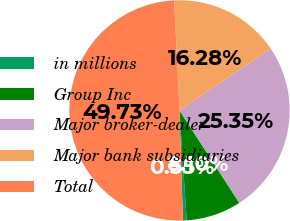Convert chart to OTSL. <chart><loc_0><loc_0><loc_500><loc_500><pie_chart><fcel>in millions<fcel>Group Inc<fcel>Major broker-dealer<fcel>Major bank subsidiaries<fcel>Total<nl><fcel>0.55%<fcel>8.1%<fcel>25.35%<fcel>16.28%<fcel>49.73%<nl></chart> 